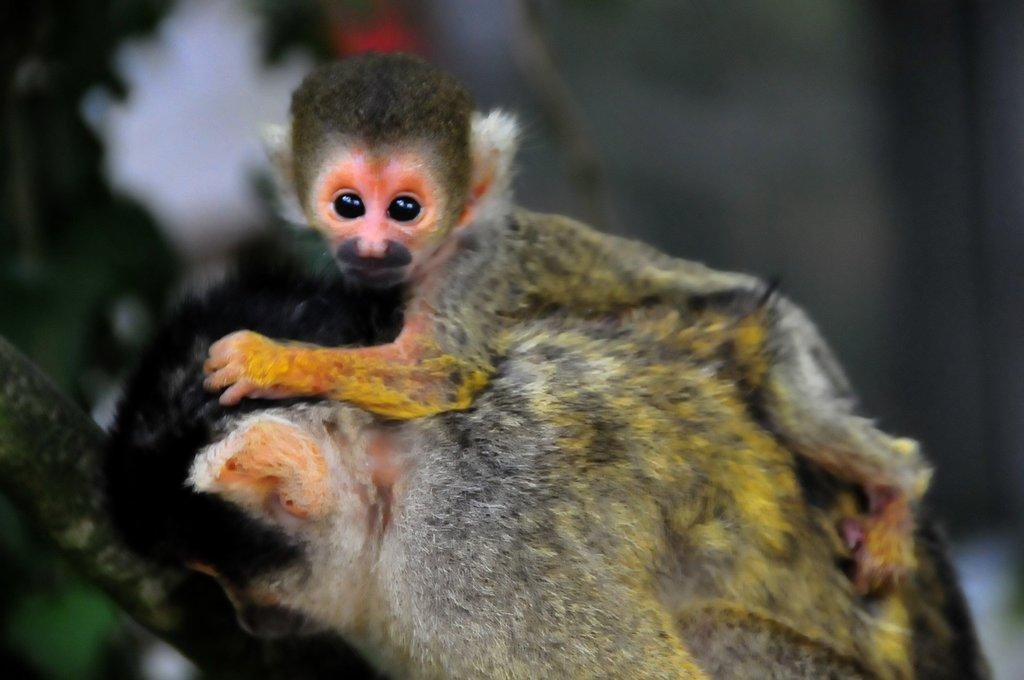How many animals are present in the image? There are two animals in the image. What colors can be seen on the animals? The animals are in gray, white, and yellow colors. Can you describe the background of the image? The background of the image is blurred. What type of clouds can be seen in the image? There are no clouds present in the image; it features two animals with a blurred background. How many wheels are visible in the image? There are no wheels present in the image. 